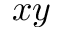<formula> <loc_0><loc_0><loc_500><loc_500>x y</formula> 